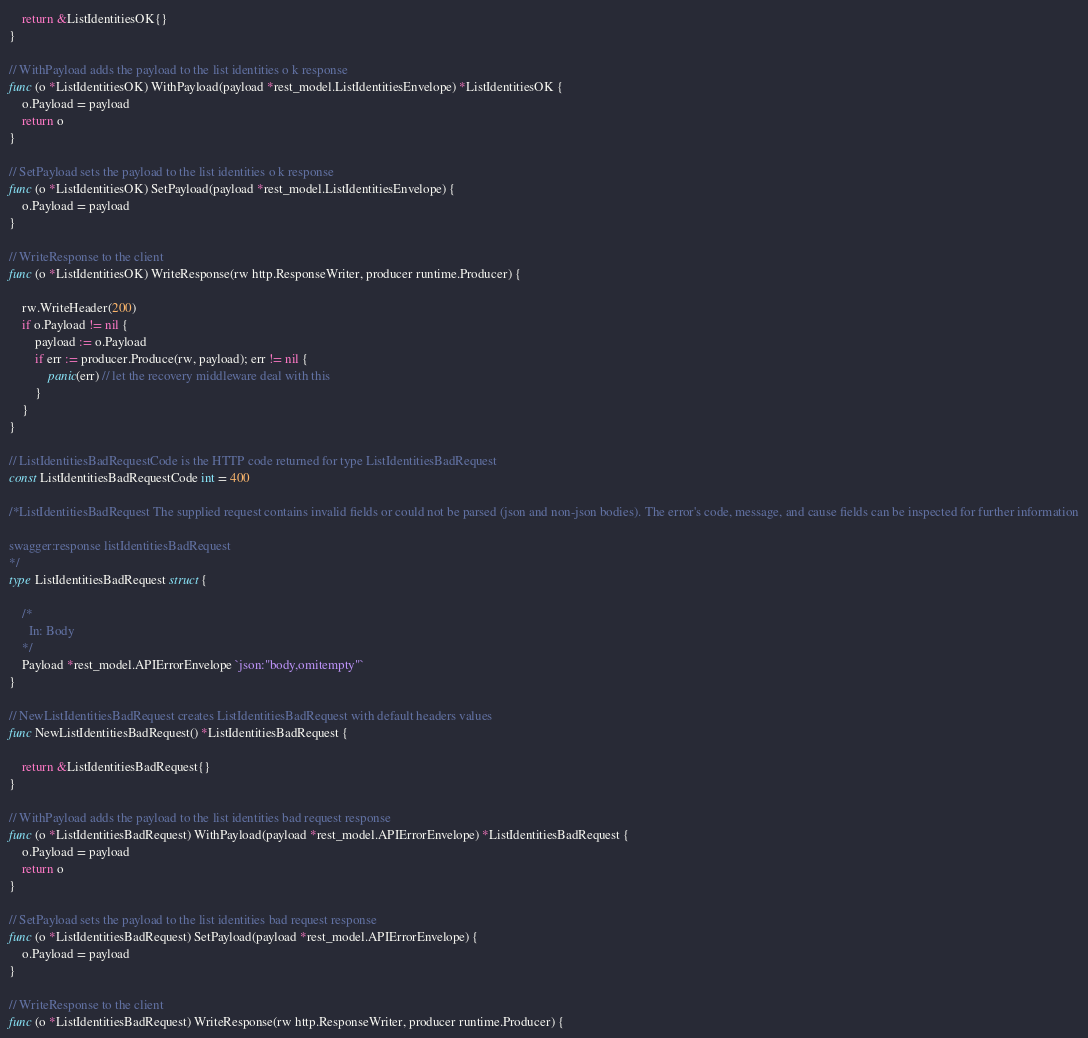Convert code to text. <code><loc_0><loc_0><loc_500><loc_500><_Go_>	return &ListIdentitiesOK{}
}

// WithPayload adds the payload to the list identities o k response
func (o *ListIdentitiesOK) WithPayload(payload *rest_model.ListIdentitiesEnvelope) *ListIdentitiesOK {
	o.Payload = payload
	return o
}

// SetPayload sets the payload to the list identities o k response
func (o *ListIdentitiesOK) SetPayload(payload *rest_model.ListIdentitiesEnvelope) {
	o.Payload = payload
}

// WriteResponse to the client
func (o *ListIdentitiesOK) WriteResponse(rw http.ResponseWriter, producer runtime.Producer) {

	rw.WriteHeader(200)
	if o.Payload != nil {
		payload := o.Payload
		if err := producer.Produce(rw, payload); err != nil {
			panic(err) // let the recovery middleware deal with this
		}
	}
}

// ListIdentitiesBadRequestCode is the HTTP code returned for type ListIdentitiesBadRequest
const ListIdentitiesBadRequestCode int = 400

/*ListIdentitiesBadRequest The supplied request contains invalid fields or could not be parsed (json and non-json bodies). The error's code, message, and cause fields can be inspected for further information

swagger:response listIdentitiesBadRequest
*/
type ListIdentitiesBadRequest struct {

	/*
	  In: Body
	*/
	Payload *rest_model.APIErrorEnvelope `json:"body,omitempty"`
}

// NewListIdentitiesBadRequest creates ListIdentitiesBadRequest with default headers values
func NewListIdentitiesBadRequest() *ListIdentitiesBadRequest {

	return &ListIdentitiesBadRequest{}
}

// WithPayload adds the payload to the list identities bad request response
func (o *ListIdentitiesBadRequest) WithPayload(payload *rest_model.APIErrorEnvelope) *ListIdentitiesBadRequest {
	o.Payload = payload
	return o
}

// SetPayload sets the payload to the list identities bad request response
func (o *ListIdentitiesBadRequest) SetPayload(payload *rest_model.APIErrorEnvelope) {
	o.Payload = payload
}

// WriteResponse to the client
func (o *ListIdentitiesBadRequest) WriteResponse(rw http.ResponseWriter, producer runtime.Producer) {
</code> 